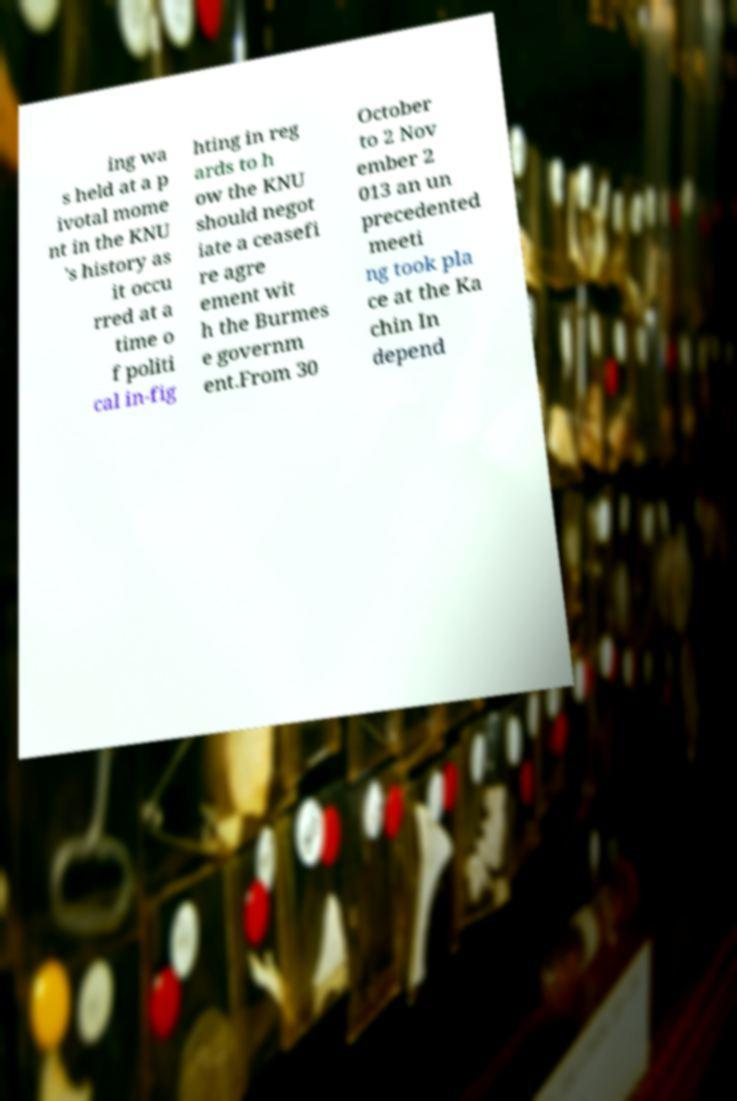What messages or text are displayed in this image? I need them in a readable, typed format. ing wa s held at a p ivotal mome nt in the KNU 's history as it occu rred at a time o f politi cal in-fig hting in reg ards to h ow the KNU should negot iate a ceasefi re agre ement wit h the Burmes e governm ent.From 30 October to 2 Nov ember 2 013 an un precedented meeti ng took pla ce at the Ka chin In depend 